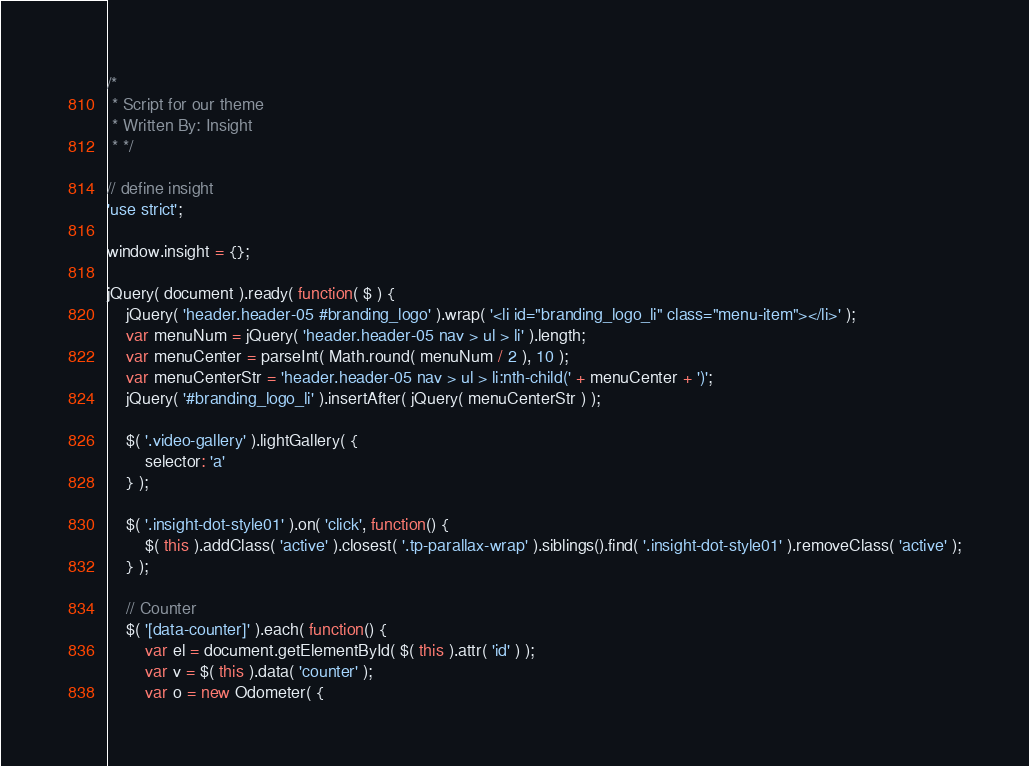Convert code to text. <code><loc_0><loc_0><loc_500><loc_500><_JavaScript_>/*
 * Script for our theme
 * Written By: Insight
 * */

// define insight
'use strict';

window.insight = {};

jQuery( document ).ready( function( $ ) {
	jQuery( 'header.header-05 #branding_logo' ).wrap( '<li id="branding_logo_li" class="menu-item"></li>' );
	var menuNum = jQuery( 'header.header-05 nav > ul > li' ).length;
	var menuCenter = parseInt( Math.round( menuNum / 2 ), 10 );
	var menuCenterStr = 'header.header-05 nav > ul > li:nth-child(' + menuCenter + ')';
	jQuery( '#branding_logo_li' ).insertAfter( jQuery( menuCenterStr ) );

	$( '.video-gallery' ).lightGallery( {
		selector: 'a'
	} );

	$( '.insight-dot-style01' ).on( 'click', function() {
		$( this ).addClass( 'active' ).closest( '.tp-parallax-wrap' ).siblings().find( '.insight-dot-style01' ).removeClass( 'active' );
	} );

	// Counter
	$( '[data-counter]' ).each( function() {
		var el = document.getElementById( $( this ).attr( 'id' ) );
		var v = $( this ).data( 'counter' );
		var o = new Odometer( {</code> 